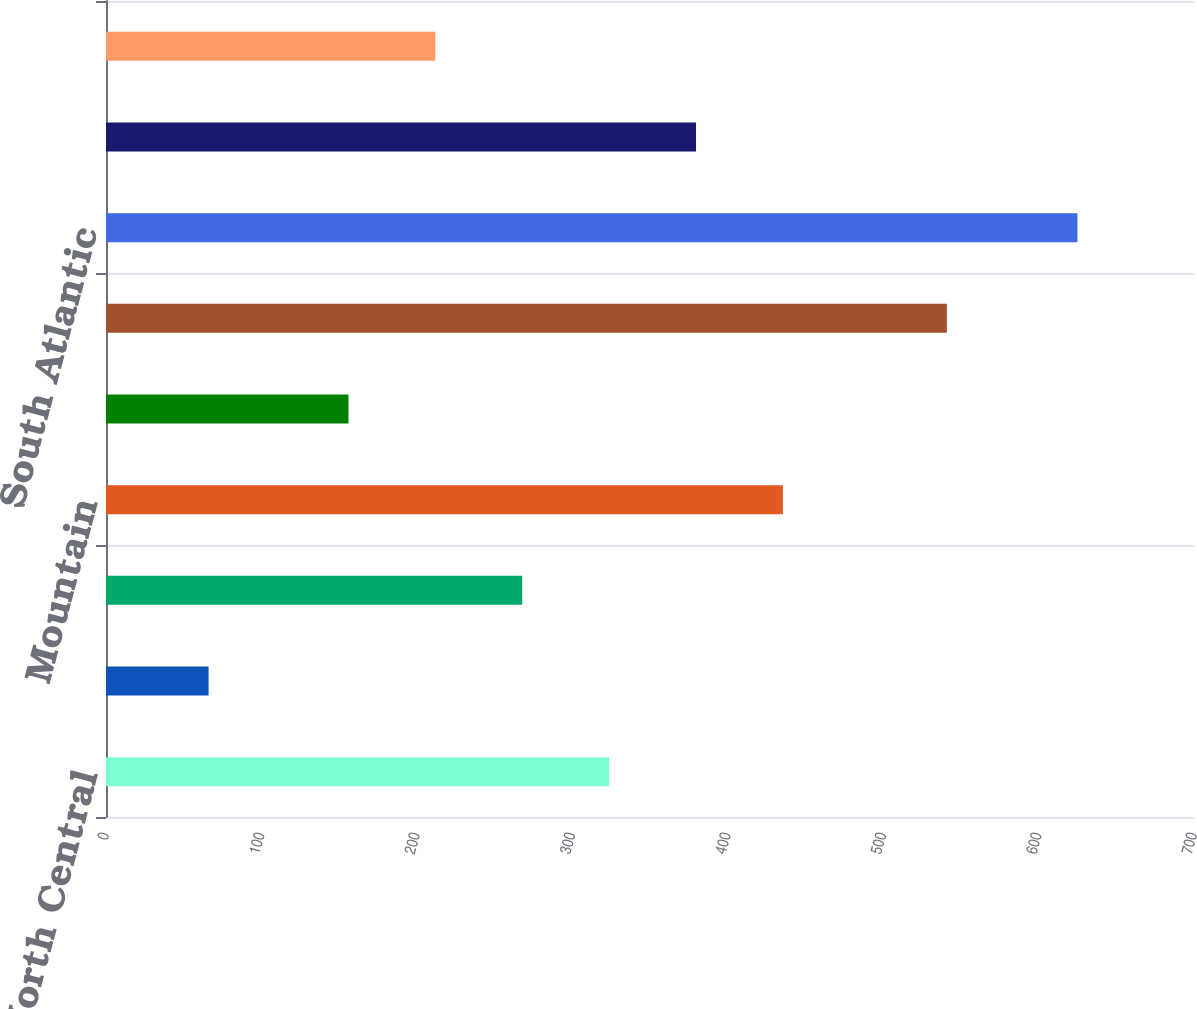<chart> <loc_0><loc_0><loc_500><loc_500><bar_chart><fcel>East North Central<fcel>East South Central<fcel>Middle Atlantic<fcel>Mountain<fcel>New England<fcel>Pacific<fcel>South Atlantic<fcel>West North Central<fcel>West South Central<nl><fcel>323.7<fcel>66<fcel>267.8<fcel>435.5<fcel>156<fcel>541<fcel>625<fcel>379.6<fcel>211.9<nl></chart> 